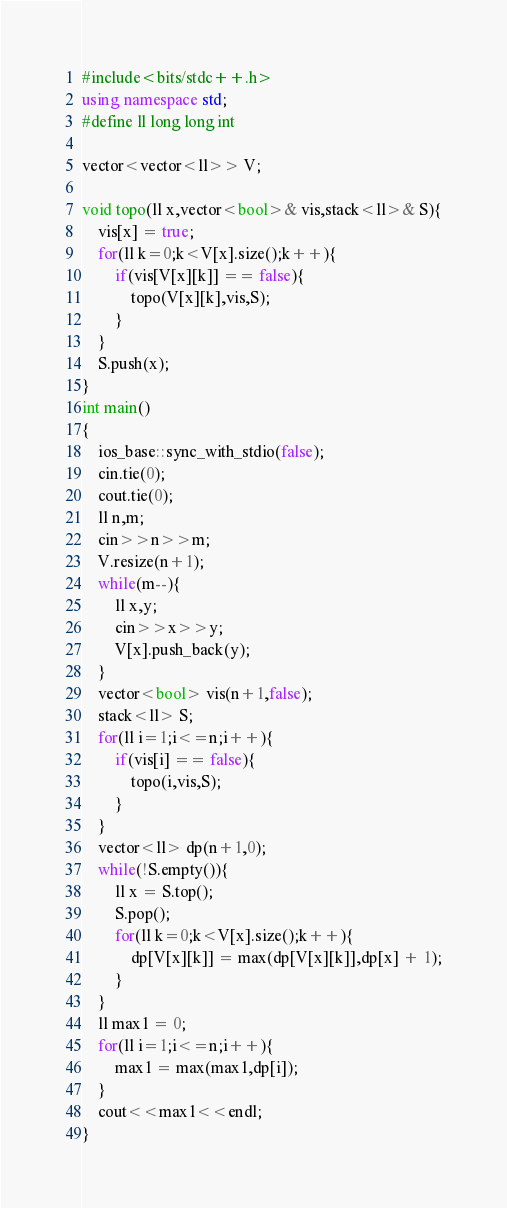<code> <loc_0><loc_0><loc_500><loc_500><_C++_>#include<bits/stdc++.h>
using namespace std;
#define ll long long int

vector<vector<ll>> V;

void topo(ll x,vector<bool>& vis,stack<ll>& S){
    vis[x] = true;
    for(ll k=0;k<V[x].size();k++){
        if(vis[V[x][k]] == false){
            topo(V[x][k],vis,S);
        }
    }
    S.push(x);
}
int main()
{
    ios_base::sync_with_stdio(false);
    cin.tie(0);
    cout.tie(0);
    ll n,m;
    cin>>n>>m;
    V.resize(n+1);
    while(m--){
        ll x,y;
        cin>>x>>y;
        V[x].push_back(y);
    }
    vector<bool> vis(n+1,false);
    stack<ll> S;
    for(ll i=1;i<=n;i++){
        if(vis[i] == false){
            topo(i,vis,S);
        }
    }
    vector<ll> dp(n+1,0);
    while(!S.empty()){
        ll x = S.top();
        S.pop();
        for(ll k=0;k<V[x].size();k++){
            dp[V[x][k]] = max(dp[V[x][k]],dp[x] + 1);
        }
    }
    ll max1 = 0;
    for(ll i=1;i<=n;i++){
        max1 = max(max1,dp[i]);
    }
    cout<<max1<<endl;
}</code> 